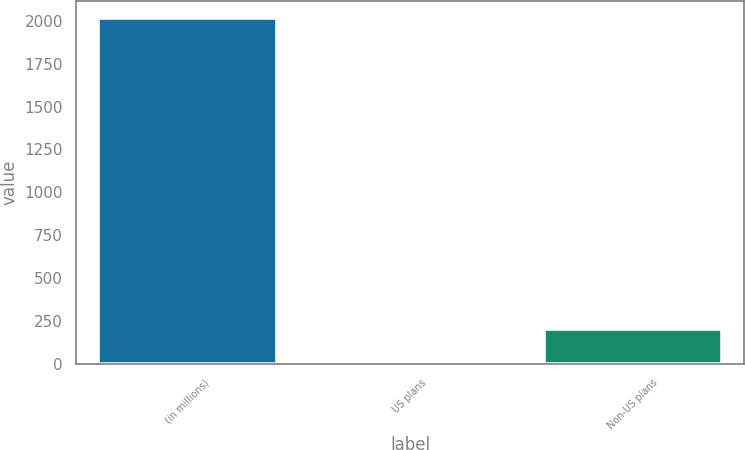Convert chart to OTSL. <chart><loc_0><loc_0><loc_500><loc_500><bar_chart><fcel>(in millions)<fcel>US plans<fcel>Non-US plans<nl><fcel>2014<fcel>5<fcel>205.9<nl></chart> 